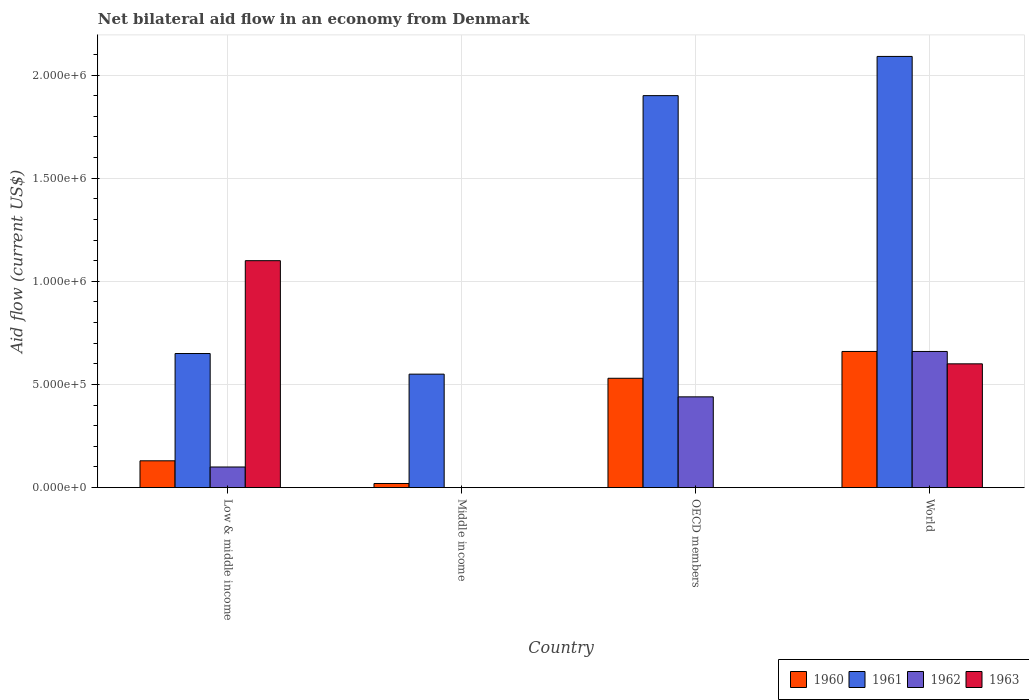How many different coloured bars are there?
Ensure brevity in your answer.  4. Are the number of bars per tick equal to the number of legend labels?
Give a very brief answer. No. How many bars are there on the 4th tick from the left?
Provide a succinct answer. 4. How many bars are there on the 3rd tick from the right?
Provide a succinct answer. 2. What is the label of the 4th group of bars from the left?
Your response must be concise. World. In how many cases, is the number of bars for a given country not equal to the number of legend labels?
Give a very brief answer. 2. What is the net bilateral aid flow in 1963 in OECD members?
Provide a short and direct response. 0. Across all countries, what is the maximum net bilateral aid flow in 1961?
Your answer should be compact. 2.09e+06. Across all countries, what is the minimum net bilateral aid flow in 1963?
Give a very brief answer. 0. In which country was the net bilateral aid flow in 1963 maximum?
Keep it short and to the point. Low & middle income. What is the total net bilateral aid flow in 1963 in the graph?
Make the answer very short. 1.70e+06. What is the difference between the net bilateral aid flow in 1960 in Middle income and that in OECD members?
Offer a very short reply. -5.10e+05. What is the average net bilateral aid flow in 1960 per country?
Offer a very short reply. 3.35e+05. What is the ratio of the net bilateral aid flow in 1960 in Middle income to that in OECD members?
Offer a terse response. 0.04. In how many countries, is the net bilateral aid flow in 1960 greater than the average net bilateral aid flow in 1960 taken over all countries?
Keep it short and to the point. 2. Is the sum of the net bilateral aid flow in 1963 in Low & middle income and World greater than the maximum net bilateral aid flow in 1962 across all countries?
Keep it short and to the point. Yes. Is it the case that in every country, the sum of the net bilateral aid flow in 1963 and net bilateral aid flow in 1962 is greater than the sum of net bilateral aid flow in 1961 and net bilateral aid flow in 1960?
Give a very brief answer. No. Are all the bars in the graph horizontal?
Make the answer very short. No. What is the difference between two consecutive major ticks on the Y-axis?
Your answer should be compact. 5.00e+05. Does the graph contain any zero values?
Your answer should be compact. Yes. Does the graph contain grids?
Your answer should be compact. Yes. How many legend labels are there?
Your response must be concise. 4. What is the title of the graph?
Your response must be concise. Net bilateral aid flow in an economy from Denmark. Does "1978" appear as one of the legend labels in the graph?
Give a very brief answer. No. What is the Aid flow (current US$) in 1961 in Low & middle income?
Ensure brevity in your answer.  6.50e+05. What is the Aid flow (current US$) in 1962 in Low & middle income?
Provide a succinct answer. 1.00e+05. What is the Aid flow (current US$) in 1963 in Low & middle income?
Your answer should be very brief. 1.10e+06. What is the Aid flow (current US$) of 1961 in Middle income?
Offer a terse response. 5.50e+05. What is the Aid flow (current US$) of 1962 in Middle income?
Offer a very short reply. 0. What is the Aid flow (current US$) in 1960 in OECD members?
Keep it short and to the point. 5.30e+05. What is the Aid flow (current US$) in 1961 in OECD members?
Provide a succinct answer. 1.90e+06. What is the Aid flow (current US$) in 1960 in World?
Provide a short and direct response. 6.60e+05. What is the Aid flow (current US$) of 1961 in World?
Offer a terse response. 2.09e+06. What is the Aid flow (current US$) of 1962 in World?
Offer a very short reply. 6.60e+05. What is the Aid flow (current US$) in 1963 in World?
Your answer should be very brief. 6.00e+05. Across all countries, what is the maximum Aid flow (current US$) of 1960?
Provide a succinct answer. 6.60e+05. Across all countries, what is the maximum Aid flow (current US$) in 1961?
Provide a short and direct response. 2.09e+06. Across all countries, what is the maximum Aid flow (current US$) of 1962?
Offer a terse response. 6.60e+05. Across all countries, what is the maximum Aid flow (current US$) in 1963?
Your response must be concise. 1.10e+06. Across all countries, what is the minimum Aid flow (current US$) in 1960?
Give a very brief answer. 2.00e+04. Across all countries, what is the minimum Aid flow (current US$) in 1962?
Offer a very short reply. 0. What is the total Aid flow (current US$) in 1960 in the graph?
Offer a terse response. 1.34e+06. What is the total Aid flow (current US$) in 1961 in the graph?
Give a very brief answer. 5.19e+06. What is the total Aid flow (current US$) of 1962 in the graph?
Your answer should be compact. 1.20e+06. What is the total Aid flow (current US$) of 1963 in the graph?
Your answer should be compact. 1.70e+06. What is the difference between the Aid flow (current US$) of 1960 in Low & middle income and that in Middle income?
Ensure brevity in your answer.  1.10e+05. What is the difference between the Aid flow (current US$) in 1961 in Low & middle income and that in Middle income?
Provide a succinct answer. 1.00e+05. What is the difference between the Aid flow (current US$) in 1960 in Low & middle income and that in OECD members?
Provide a succinct answer. -4.00e+05. What is the difference between the Aid flow (current US$) of 1961 in Low & middle income and that in OECD members?
Ensure brevity in your answer.  -1.25e+06. What is the difference between the Aid flow (current US$) in 1962 in Low & middle income and that in OECD members?
Your answer should be very brief. -3.40e+05. What is the difference between the Aid flow (current US$) in 1960 in Low & middle income and that in World?
Your answer should be very brief. -5.30e+05. What is the difference between the Aid flow (current US$) in 1961 in Low & middle income and that in World?
Ensure brevity in your answer.  -1.44e+06. What is the difference between the Aid flow (current US$) of 1962 in Low & middle income and that in World?
Your answer should be very brief. -5.60e+05. What is the difference between the Aid flow (current US$) in 1960 in Middle income and that in OECD members?
Provide a succinct answer. -5.10e+05. What is the difference between the Aid flow (current US$) in 1961 in Middle income and that in OECD members?
Your answer should be compact. -1.35e+06. What is the difference between the Aid flow (current US$) of 1960 in Middle income and that in World?
Keep it short and to the point. -6.40e+05. What is the difference between the Aid flow (current US$) in 1961 in Middle income and that in World?
Offer a very short reply. -1.54e+06. What is the difference between the Aid flow (current US$) in 1960 in Low & middle income and the Aid flow (current US$) in 1961 in Middle income?
Ensure brevity in your answer.  -4.20e+05. What is the difference between the Aid flow (current US$) in 1960 in Low & middle income and the Aid flow (current US$) in 1961 in OECD members?
Give a very brief answer. -1.77e+06. What is the difference between the Aid flow (current US$) of 1960 in Low & middle income and the Aid flow (current US$) of 1962 in OECD members?
Your response must be concise. -3.10e+05. What is the difference between the Aid flow (current US$) in 1960 in Low & middle income and the Aid flow (current US$) in 1961 in World?
Your answer should be very brief. -1.96e+06. What is the difference between the Aid flow (current US$) in 1960 in Low & middle income and the Aid flow (current US$) in 1962 in World?
Provide a short and direct response. -5.30e+05. What is the difference between the Aid flow (current US$) of 1960 in Low & middle income and the Aid flow (current US$) of 1963 in World?
Your answer should be very brief. -4.70e+05. What is the difference between the Aid flow (current US$) of 1962 in Low & middle income and the Aid flow (current US$) of 1963 in World?
Ensure brevity in your answer.  -5.00e+05. What is the difference between the Aid flow (current US$) of 1960 in Middle income and the Aid flow (current US$) of 1961 in OECD members?
Provide a short and direct response. -1.88e+06. What is the difference between the Aid flow (current US$) in 1960 in Middle income and the Aid flow (current US$) in 1962 in OECD members?
Make the answer very short. -4.20e+05. What is the difference between the Aid flow (current US$) in 1961 in Middle income and the Aid flow (current US$) in 1962 in OECD members?
Give a very brief answer. 1.10e+05. What is the difference between the Aid flow (current US$) of 1960 in Middle income and the Aid flow (current US$) of 1961 in World?
Your response must be concise. -2.07e+06. What is the difference between the Aid flow (current US$) of 1960 in Middle income and the Aid flow (current US$) of 1962 in World?
Ensure brevity in your answer.  -6.40e+05. What is the difference between the Aid flow (current US$) of 1960 in Middle income and the Aid flow (current US$) of 1963 in World?
Give a very brief answer. -5.80e+05. What is the difference between the Aid flow (current US$) of 1961 in Middle income and the Aid flow (current US$) of 1962 in World?
Ensure brevity in your answer.  -1.10e+05. What is the difference between the Aid flow (current US$) in 1960 in OECD members and the Aid flow (current US$) in 1961 in World?
Provide a succinct answer. -1.56e+06. What is the difference between the Aid flow (current US$) in 1960 in OECD members and the Aid flow (current US$) in 1962 in World?
Make the answer very short. -1.30e+05. What is the difference between the Aid flow (current US$) in 1960 in OECD members and the Aid flow (current US$) in 1963 in World?
Keep it short and to the point. -7.00e+04. What is the difference between the Aid flow (current US$) in 1961 in OECD members and the Aid flow (current US$) in 1962 in World?
Offer a very short reply. 1.24e+06. What is the difference between the Aid flow (current US$) of 1961 in OECD members and the Aid flow (current US$) of 1963 in World?
Offer a very short reply. 1.30e+06. What is the average Aid flow (current US$) of 1960 per country?
Give a very brief answer. 3.35e+05. What is the average Aid flow (current US$) of 1961 per country?
Provide a short and direct response. 1.30e+06. What is the average Aid flow (current US$) in 1963 per country?
Provide a short and direct response. 4.25e+05. What is the difference between the Aid flow (current US$) of 1960 and Aid flow (current US$) of 1961 in Low & middle income?
Offer a terse response. -5.20e+05. What is the difference between the Aid flow (current US$) in 1960 and Aid flow (current US$) in 1963 in Low & middle income?
Offer a very short reply. -9.70e+05. What is the difference between the Aid flow (current US$) of 1961 and Aid flow (current US$) of 1962 in Low & middle income?
Give a very brief answer. 5.50e+05. What is the difference between the Aid flow (current US$) in 1961 and Aid flow (current US$) in 1963 in Low & middle income?
Offer a terse response. -4.50e+05. What is the difference between the Aid flow (current US$) of 1962 and Aid flow (current US$) of 1963 in Low & middle income?
Your response must be concise. -1.00e+06. What is the difference between the Aid flow (current US$) in 1960 and Aid flow (current US$) in 1961 in Middle income?
Your response must be concise. -5.30e+05. What is the difference between the Aid flow (current US$) of 1960 and Aid flow (current US$) of 1961 in OECD members?
Keep it short and to the point. -1.37e+06. What is the difference between the Aid flow (current US$) in 1961 and Aid flow (current US$) in 1962 in OECD members?
Your answer should be very brief. 1.46e+06. What is the difference between the Aid flow (current US$) in 1960 and Aid flow (current US$) in 1961 in World?
Ensure brevity in your answer.  -1.43e+06. What is the difference between the Aid flow (current US$) in 1960 and Aid flow (current US$) in 1962 in World?
Keep it short and to the point. 0. What is the difference between the Aid flow (current US$) of 1961 and Aid flow (current US$) of 1962 in World?
Ensure brevity in your answer.  1.43e+06. What is the difference between the Aid flow (current US$) of 1961 and Aid flow (current US$) of 1963 in World?
Your response must be concise. 1.49e+06. What is the difference between the Aid flow (current US$) in 1962 and Aid flow (current US$) in 1963 in World?
Give a very brief answer. 6.00e+04. What is the ratio of the Aid flow (current US$) of 1961 in Low & middle income to that in Middle income?
Your response must be concise. 1.18. What is the ratio of the Aid flow (current US$) of 1960 in Low & middle income to that in OECD members?
Offer a very short reply. 0.25. What is the ratio of the Aid flow (current US$) of 1961 in Low & middle income to that in OECD members?
Provide a short and direct response. 0.34. What is the ratio of the Aid flow (current US$) in 1962 in Low & middle income to that in OECD members?
Provide a succinct answer. 0.23. What is the ratio of the Aid flow (current US$) in 1960 in Low & middle income to that in World?
Your answer should be very brief. 0.2. What is the ratio of the Aid flow (current US$) of 1961 in Low & middle income to that in World?
Your answer should be very brief. 0.31. What is the ratio of the Aid flow (current US$) in 1962 in Low & middle income to that in World?
Offer a terse response. 0.15. What is the ratio of the Aid flow (current US$) of 1963 in Low & middle income to that in World?
Your response must be concise. 1.83. What is the ratio of the Aid flow (current US$) in 1960 in Middle income to that in OECD members?
Make the answer very short. 0.04. What is the ratio of the Aid flow (current US$) in 1961 in Middle income to that in OECD members?
Offer a terse response. 0.29. What is the ratio of the Aid flow (current US$) of 1960 in Middle income to that in World?
Your response must be concise. 0.03. What is the ratio of the Aid flow (current US$) of 1961 in Middle income to that in World?
Your answer should be very brief. 0.26. What is the ratio of the Aid flow (current US$) of 1960 in OECD members to that in World?
Your answer should be compact. 0.8. What is the ratio of the Aid flow (current US$) in 1962 in OECD members to that in World?
Provide a short and direct response. 0.67. What is the difference between the highest and the second highest Aid flow (current US$) in 1960?
Provide a short and direct response. 1.30e+05. What is the difference between the highest and the second highest Aid flow (current US$) in 1961?
Your answer should be compact. 1.90e+05. What is the difference between the highest and the second highest Aid flow (current US$) of 1962?
Your answer should be compact. 2.20e+05. What is the difference between the highest and the lowest Aid flow (current US$) in 1960?
Offer a very short reply. 6.40e+05. What is the difference between the highest and the lowest Aid flow (current US$) in 1961?
Offer a very short reply. 1.54e+06. What is the difference between the highest and the lowest Aid flow (current US$) of 1962?
Offer a terse response. 6.60e+05. What is the difference between the highest and the lowest Aid flow (current US$) of 1963?
Your answer should be compact. 1.10e+06. 